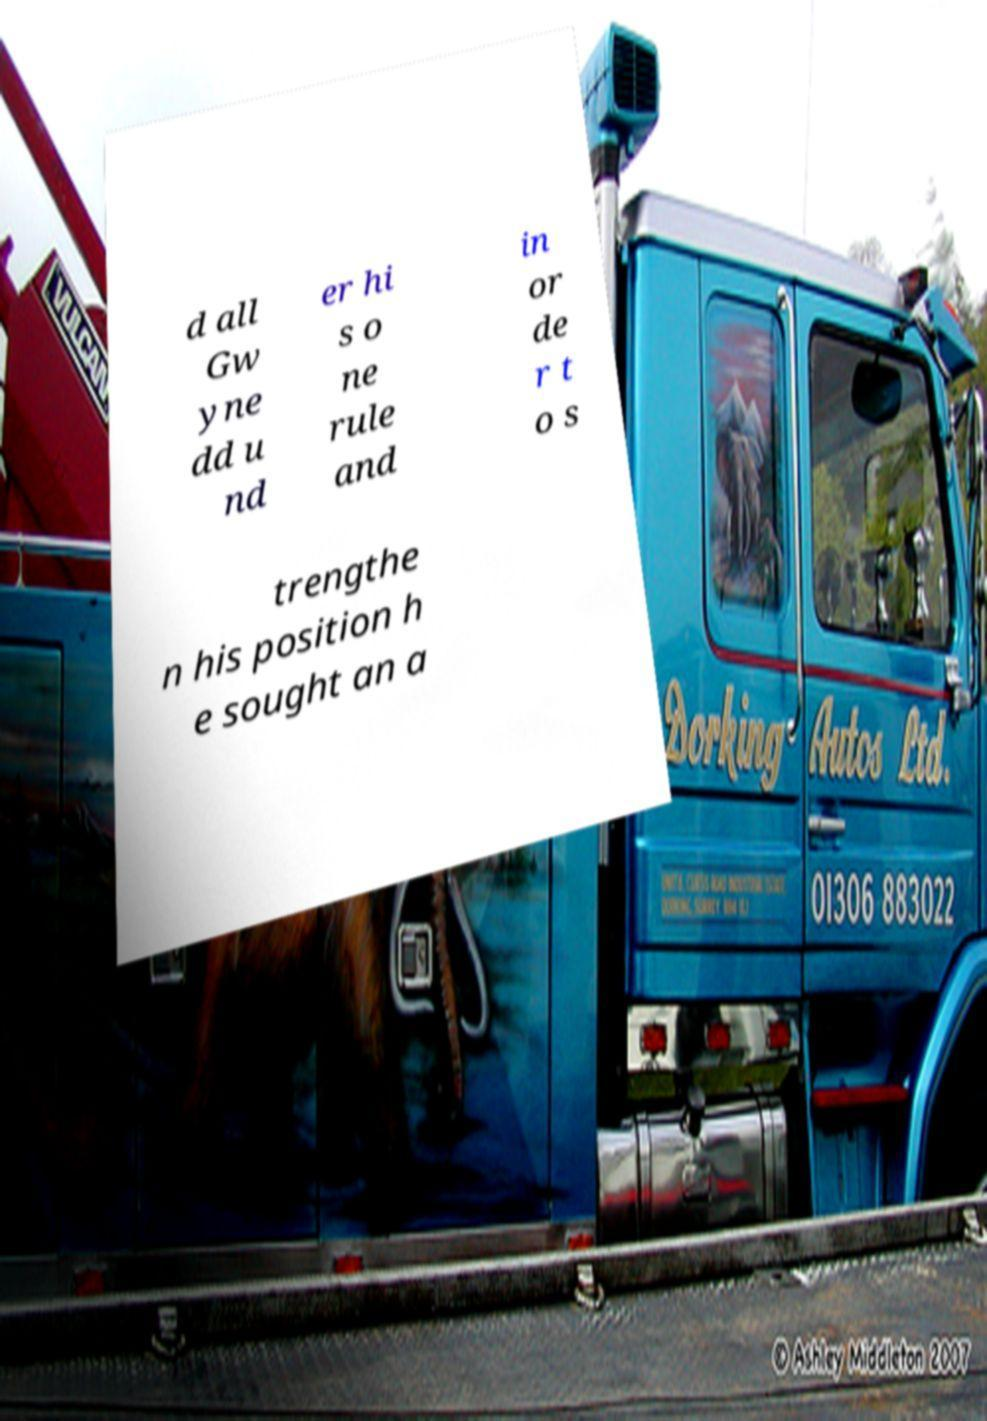Please read and relay the text visible in this image. What does it say? d all Gw yne dd u nd er hi s o ne rule and in or de r t o s trengthe n his position h e sought an a 